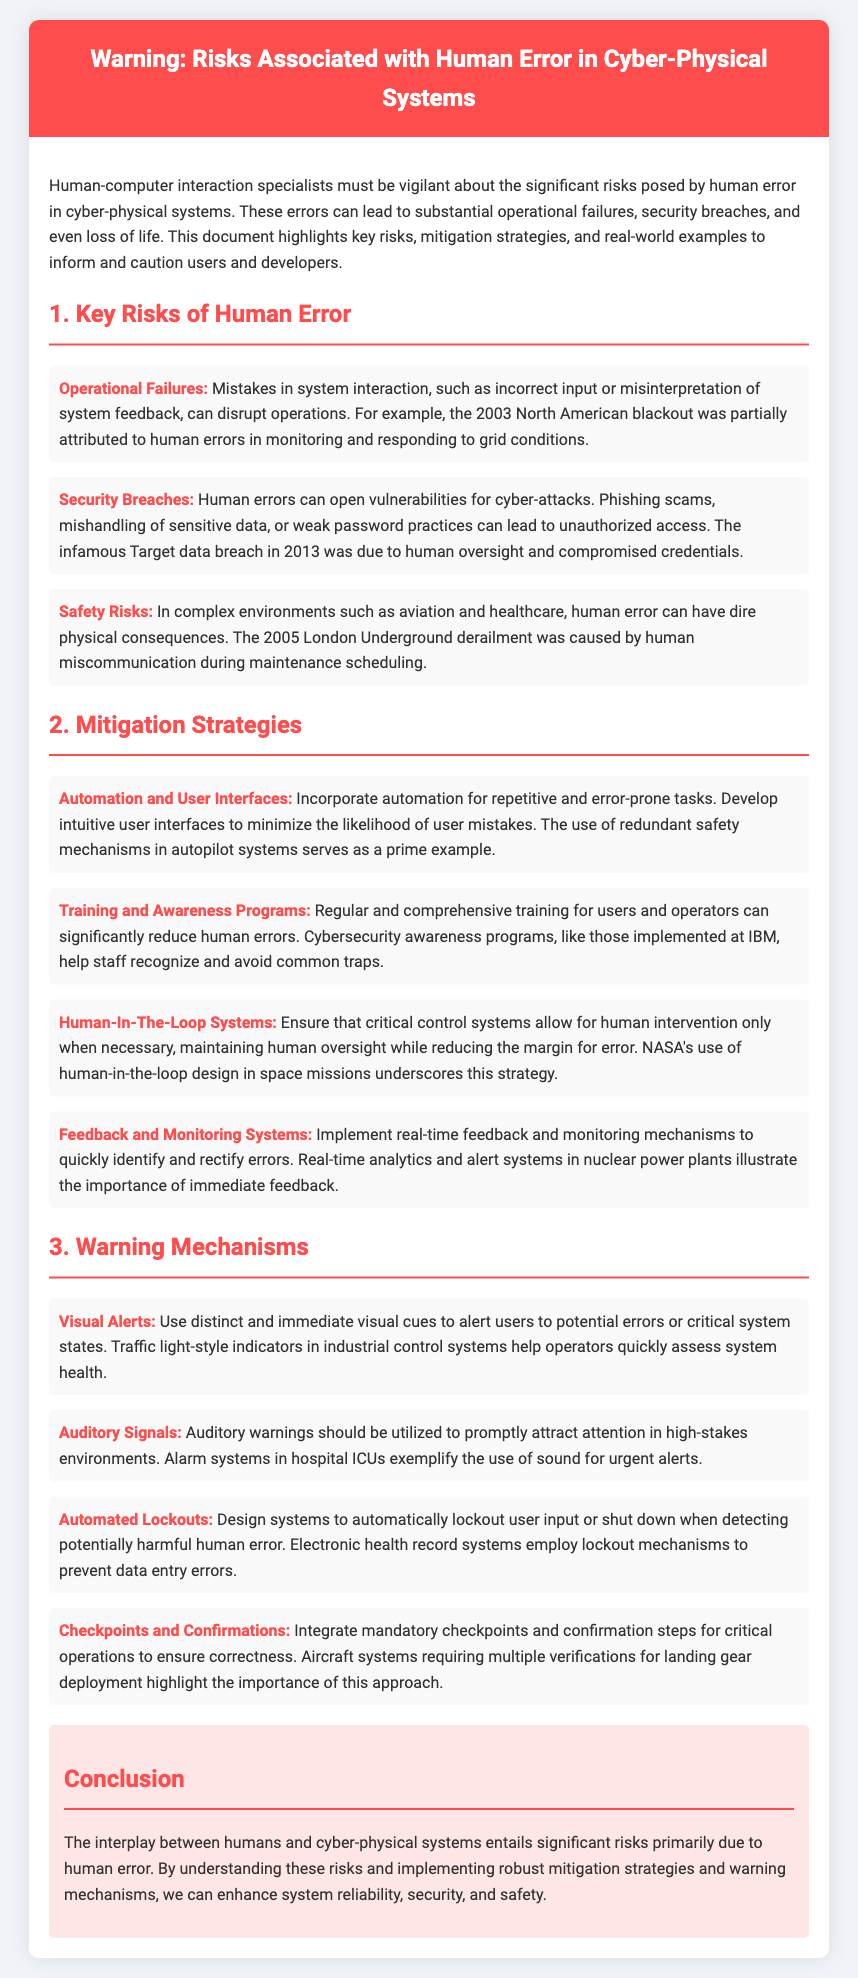What is the main theme of the document? The main theme revolves around the risks associated with human error in cyber-physical systems and how to mitigate them.
Answer: Risks associated with human error What incident was partly attributed to human error in monitoring? The document states that the 2003 North American blackout was partially due to human errors.
Answer: 2003 North American blackout What company implemented cybersecurity awareness programs? IBM is mentioned as having implemented such programs to reduce human errors.
Answer: IBM Which strategy involves the use of automation for error-prone tasks? The document refers to incorporating automation as a mitigation strategy for repetitive tasks.
Answer: Automation and User Interfaces What type of alerts should be used to catch users' attention? The document recommends using distinct and immediate visual cues for alerts.
Answer: Visual Alerts How many types of mitigation strategies are listed? There are four different mitigation strategies provided in the document.
Answer: Four What was a cause of the 2005 London Underground derailment? Human miscommunication during maintenance scheduling is cited as a cause.
Answer: Human miscommunication Which warning mechanism prevents data entry errors? The document states that electronic health record systems use lockout mechanisms for this purpose.
Answer: Automated Lockouts What color theme is used in the warning header? The header background color is described as red.
Answer: Red 